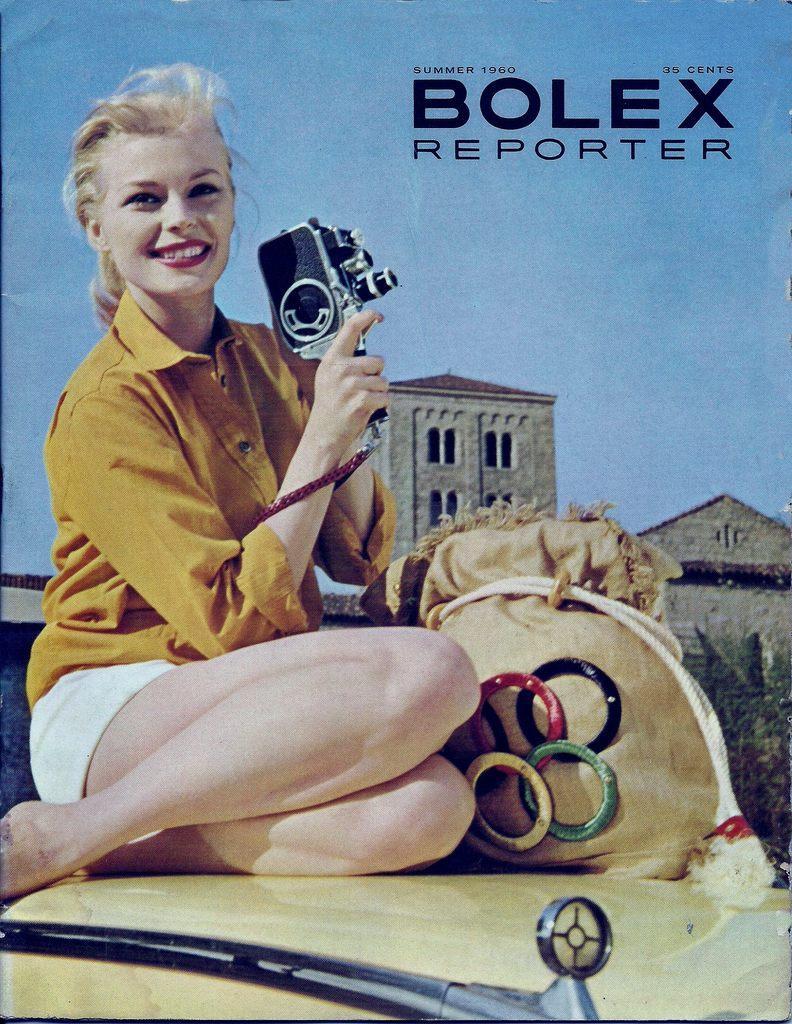In one or two sentences, can you explain what this image depicts? In this image there is a poster of a woman wearing yellow shirt sitting on the car and holding the black color camera and giving a pose. Behind there are some old buildings. 